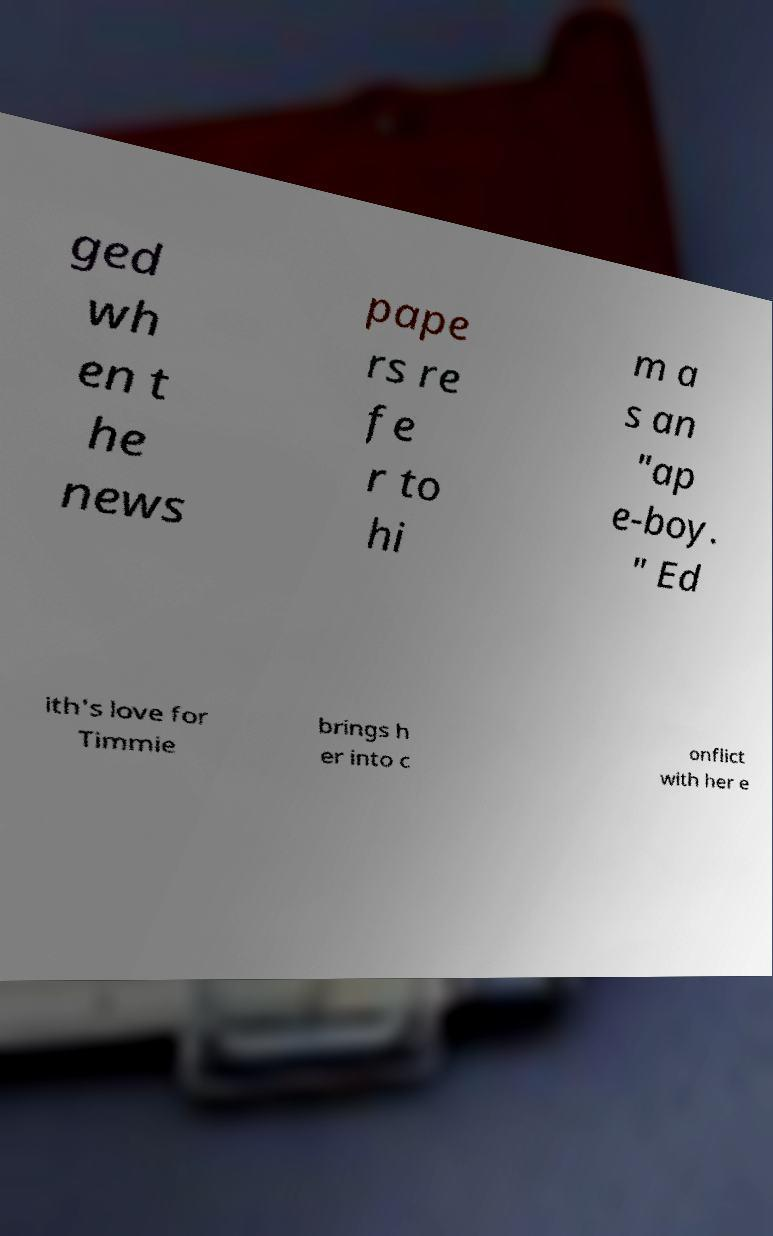I need the written content from this picture converted into text. Can you do that? ged wh en t he news pape rs re fe r to hi m a s an "ap e-boy. " Ed ith's love for Timmie brings h er into c onflict with her e 